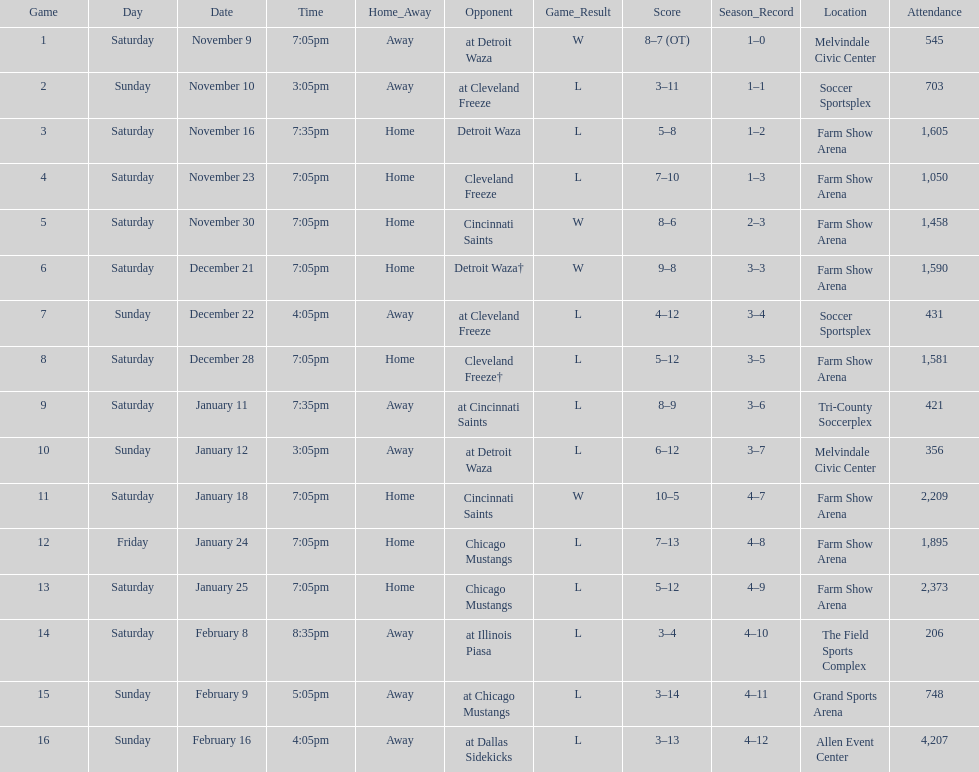How many times did the team play at home but did not win? 5. 